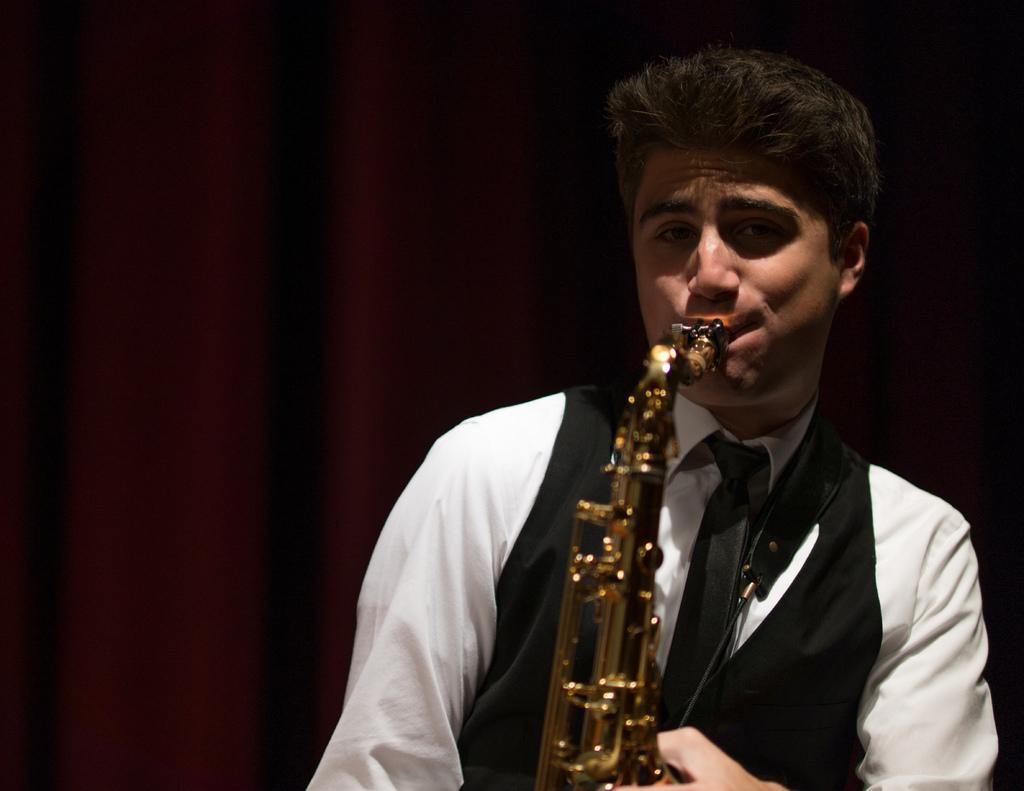What is the main subject of the image? There is a person in the image. What is the person doing in the image? The person is playing a musical instrument. What can be seen in the background of the image? There is a maroon curtain in the background of the image. What type of skirt is the person wearing in the image? The image does not show the person wearing a skirt, so it cannot be determined from the image. 